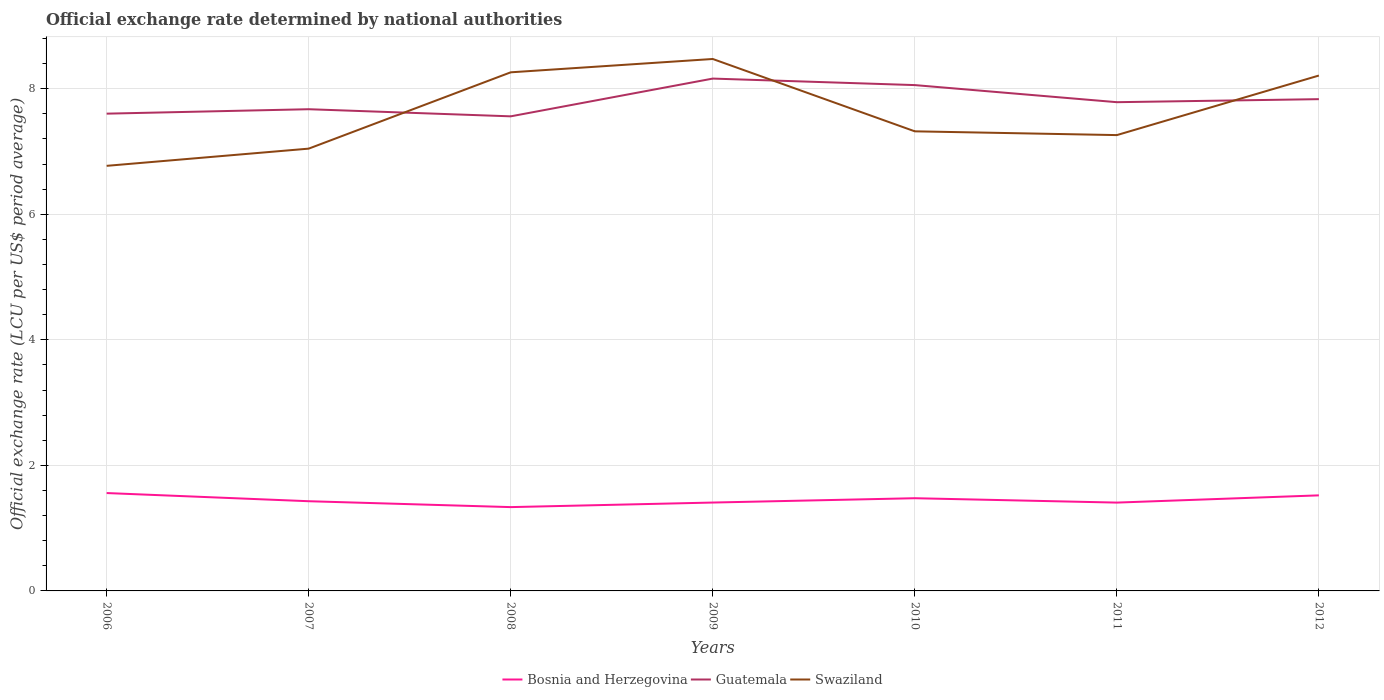How many different coloured lines are there?
Offer a very short reply. 3. Across all years, what is the maximum official exchange rate in Swaziland?
Keep it short and to the point. 6.77. What is the total official exchange rate in Swaziland in the graph?
Make the answer very short. -0.49. What is the difference between the highest and the second highest official exchange rate in Swaziland?
Ensure brevity in your answer.  1.7. Is the official exchange rate in Swaziland strictly greater than the official exchange rate in Guatemala over the years?
Give a very brief answer. No. Does the graph contain grids?
Provide a short and direct response. Yes. Where does the legend appear in the graph?
Provide a short and direct response. Bottom center. How are the legend labels stacked?
Ensure brevity in your answer.  Horizontal. What is the title of the graph?
Ensure brevity in your answer.  Official exchange rate determined by national authorities. Does "Peru" appear as one of the legend labels in the graph?
Give a very brief answer. No. What is the label or title of the X-axis?
Offer a very short reply. Years. What is the label or title of the Y-axis?
Give a very brief answer. Official exchange rate (LCU per US$ period average). What is the Official exchange rate (LCU per US$ period average) of Bosnia and Herzegovina in 2006?
Your answer should be very brief. 1.56. What is the Official exchange rate (LCU per US$ period average) of Guatemala in 2006?
Provide a succinct answer. 7.6. What is the Official exchange rate (LCU per US$ period average) of Swaziland in 2006?
Give a very brief answer. 6.77. What is the Official exchange rate (LCU per US$ period average) in Bosnia and Herzegovina in 2007?
Offer a terse response. 1.43. What is the Official exchange rate (LCU per US$ period average) of Guatemala in 2007?
Your answer should be very brief. 7.67. What is the Official exchange rate (LCU per US$ period average) in Swaziland in 2007?
Ensure brevity in your answer.  7.05. What is the Official exchange rate (LCU per US$ period average) of Bosnia and Herzegovina in 2008?
Offer a terse response. 1.34. What is the Official exchange rate (LCU per US$ period average) of Guatemala in 2008?
Keep it short and to the point. 7.56. What is the Official exchange rate (LCU per US$ period average) of Swaziland in 2008?
Keep it short and to the point. 8.26. What is the Official exchange rate (LCU per US$ period average) of Bosnia and Herzegovina in 2009?
Ensure brevity in your answer.  1.41. What is the Official exchange rate (LCU per US$ period average) of Guatemala in 2009?
Ensure brevity in your answer.  8.16. What is the Official exchange rate (LCU per US$ period average) of Swaziland in 2009?
Your answer should be very brief. 8.47. What is the Official exchange rate (LCU per US$ period average) of Bosnia and Herzegovina in 2010?
Your answer should be very brief. 1.48. What is the Official exchange rate (LCU per US$ period average) of Guatemala in 2010?
Provide a succinct answer. 8.06. What is the Official exchange rate (LCU per US$ period average) of Swaziland in 2010?
Provide a succinct answer. 7.32. What is the Official exchange rate (LCU per US$ period average) in Bosnia and Herzegovina in 2011?
Offer a very short reply. 1.41. What is the Official exchange rate (LCU per US$ period average) of Guatemala in 2011?
Make the answer very short. 7.79. What is the Official exchange rate (LCU per US$ period average) in Swaziland in 2011?
Offer a terse response. 7.26. What is the Official exchange rate (LCU per US$ period average) in Bosnia and Herzegovina in 2012?
Offer a terse response. 1.52. What is the Official exchange rate (LCU per US$ period average) in Guatemala in 2012?
Your answer should be very brief. 7.83. What is the Official exchange rate (LCU per US$ period average) of Swaziland in 2012?
Ensure brevity in your answer.  8.21. Across all years, what is the maximum Official exchange rate (LCU per US$ period average) of Bosnia and Herzegovina?
Provide a succinct answer. 1.56. Across all years, what is the maximum Official exchange rate (LCU per US$ period average) of Guatemala?
Offer a terse response. 8.16. Across all years, what is the maximum Official exchange rate (LCU per US$ period average) in Swaziland?
Provide a succinct answer. 8.47. Across all years, what is the minimum Official exchange rate (LCU per US$ period average) in Bosnia and Herzegovina?
Offer a very short reply. 1.34. Across all years, what is the minimum Official exchange rate (LCU per US$ period average) in Guatemala?
Keep it short and to the point. 7.56. Across all years, what is the minimum Official exchange rate (LCU per US$ period average) in Swaziland?
Ensure brevity in your answer.  6.77. What is the total Official exchange rate (LCU per US$ period average) of Bosnia and Herzegovina in the graph?
Offer a terse response. 10.14. What is the total Official exchange rate (LCU per US$ period average) in Guatemala in the graph?
Offer a terse response. 54.67. What is the total Official exchange rate (LCU per US$ period average) in Swaziland in the graph?
Your answer should be compact. 53.34. What is the difference between the Official exchange rate (LCU per US$ period average) of Bosnia and Herzegovina in 2006 and that in 2007?
Your response must be concise. 0.13. What is the difference between the Official exchange rate (LCU per US$ period average) of Guatemala in 2006 and that in 2007?
Your answer should be very brief. -0.07. What is the difference between the Official exchange rate (LCU per US$ period average) in Swaziland in 2006 and that in 2007?
Make the answer very short. -0.27. What is the difference between the Official exchange rate (LCU per US$ period average) of Bosnia and Herzegovina in 2006 and that in 2008?
Offer a very short reply. 0.22. What is the difference between the Official exchange rate (LCU per US$ period average) in Guatemala in 2006 and that in 2008?
Your answer should be very brief. 0.04. What is the difference between the Official exchange rate (LCU per US$ period average) of Swaziland in 2006 and that in 2008?
Offer a very short reply. -1.49. What is the difference between the Official exchange rate (LCU per US$ period average) of Bosnia and Herzegovina in 2006 and that in 2009?
Your answer should be compact. 0.15. What is the difference between the Official exchange rate (LCU per US$ period average) of Guatemala in 2006 and that in 2009?
Provide a short and direct response. -0.56. What is the difference between the Official exchange rate (LCU per US$ period average) in Swaziland in 2006 and that in 2009?
Your response must be concise. -1.7. What is the difference between the Official exchange rate (LCU per US$ period average) of Bosnia and Herzegovina in 2006 and that in 2010?
Offer a terse response. 0.08. What is the difference between the Official exchange rate (LCU per US$ period average) in Guatemala in 2006 and that in 2010?
Provide a short and direct response. -0.46. What is the difference between the Official exchange rate (LCU per US$ period average) in Swaziland in 2006 and that in 2010?
Ensure brevity in your answer.  -0.55. What is the difference between the Official exchange rate (LCU per US$ period average) of Bosnia and Herzegovina in 2006 and that in 2011?
Provide a short and direct response. 0.15. What is the difference between the Official exchange rate (LCU per US$ period average) of Guatemala in 2006 and that in 2011?
Make the answer very short. -0.18. What is the difference between the Official exchange rate (LCU per US$ period average) in Swaziland in 2006 and that in 2011?
Keep it short and to the point. -0.49. What is the difference between the Official exchange rate (LCU per US$ period average) of Bosnia and Herzegovina in 2006 and that in 2012?
Give a very brief answer. 0.04. What is the difference between the Official exchange rate (LCU per US$ period average) of Guatemala in 2006 and that in 2012?
Ensure brevity in your answer.  -0.23. What is the difference between the Official exchange rate (LCU per US$ period average) of Swaziland in 2006 and that in 2012?
Provide a succinct answer. -1.44. What is the difference between the Official exchange rate (LCU per US$ period average) of Bosnia and Herzegovina in 2007 and that in 2008?
Make the answer very short. 0.09. What is the difference between the Official exchange rate (LCU per US$ period average) of Guatemala in 2007 and that in 2008?
Provide a short and direct response. 0.11. What is the difference between the Official exchange rate (LCU per US$ period average) of Swaziland in 2007 and that in 2008?
Offer a very short reply. -1.22. What is the difference between the Official exchange rate (LCU per US$ period average) in Bosnia and Herzegovina in 2007 and that in 2009?
Make the answer very short. 0.02. What is the difference between the Official exchange rate (LCU per US$ period average) of Guatemala in 2007 and that in 2009?
Provide a succinct answer. -0.49. What is the difference between the Official exchange rate (LCU per US$ period average) in Swaziland in 2007 and that in 2009?
Offer a terse response. -1.43. What is the difference between the Official exchange rate (LCU per US$ period average) in Bosnia and Herzegovina in 2007 and that in 2010?
Ensure brevity in your answer.  -0.05. What is the difference between the Official exchange rate (LCU per US$ period average) of Guatemala in 2007 and that in 2010?
Give a very brief answer. -0.38. What is the difference between the Official exchange rate (LCU per US$ period average) of Swaziland in 2007 and that in 2010?
Keep it short and to the point. -0.28. What is the difference between the Official exchange rate (LCU per US$ period average) of Bosnia and Herzegovina in 2007 and that in 2011?
Make the answer very short. 0.02. What is the difference between the Official exchange rate (LCU per US$ period average) in Guatemala in 2007 and that in 2011?
Make the answer very short. -0.11. What is the difference between the Official exchange rate (LCU per US$ period average) of Swaziland in 2007 and that in 2011?
Your answer should be very brief. -0.22. What is the difference between the Official exchange rate (LCU per US$ period average) of Bosnia and Herzegovina in 2007 and that in 2012?
Your answer should be very brief. -0.09. What is the difference between the Official exchange rate (LCU per US$ period average) of Guatemala in 2007 and that in 2012?
Give a very brief answer. -0.16. What is the difference between the Official exchange rate (LCU per US$ period average) in Swaziland in 2007 and that in 2012?
Your response must be concise. -1.16. What is the difference between the Official exchange rate (LCU per US$ period average) of Bosnia and Herzegovina in 2008 and that in 2009?
Your answer should be very brief. -0.07. What is the difference between the Official exchange rate (LCU per US$ period average) of Guatemala in 2008 and that in 2009?
Provide a succinct answer. -0.6. What is the difference between the Official exchange rate (LCU per US$ period average) in Swaziland in 2008 and that in 2009?
Make the answer very short. -0.21. What is the difference between the Official exchange rate (LCU per US$ period average) of Bosnia and Herzegovina in 2008 and that in 2010?
Provide a short and direct response. -0.14. What is the difference between the Official exchange rate (LCU per US$ period average) in Guatemala in 2008 and that in 2010?
Give a very brief answer. -0.5. What is the difference between the Official exchange rate (LCU per US$ period average) in Bosnia and Herzegovina in 2008 and that in 2011?
Offer a terse response. -0.07. What is the difference between the Official exchange rate (LCU per US$ period average) of Guatemala in 2008 and that in 2011?
Your answer should be very brief. -0.23. What is the difference between the Official exchange rate (LCU per US$ period average) of Bosnia and Herzegovina in 2008 and that in 2012?
Your answer should be compact. -0.19. What is the difference between the Official exchange rate (LCU per US$ period average) in Guatemala in 2008 and that in 2012?
Provide a succinct answer. -0.27. What is the difference between the Official exchange rate (LCU per US$ period average) of Swaziland in 2008 and that in 2012?
Keep it short and to the point. 0.05. What is the difference between the Official exchange rate (LCU per US$ period average) of Bosnia and Herzegovina in 2009 and that in 2010?
Ensure brevity in your answer.  -0.07. What is the difference between the Official exchange rate (LCU per US$ period average) of Guatemala in 2009 and that in 2010?
Ensure brevity in your answer.  0.1. What is the difference between the Official exchange rate (LCU per US$ period average) of Swaziland in 2009 and that in 2010?
Provide a succinct answer. 1.15. What is the difference between the Official exchange rate (LCU per US$ period average) of Guatemala in 2009 and that in 2011?
Offer a very short reply. 0.38. What is the difference between the Official exchange rate (LCU per US$ period average) in Swaziland in 2009 and that in 2011?
Give a very brief answer. 1.21. What is the difference between the Official exchange rate (LCU per US$ period average) of Bosnia and Herzegovina in 2009 and that in 2012?
Your response must be concise. -0.11. What is the difference between the Official exchange rate (LCU per US$ period average) in Guatemala in 2009 and that in 2012?
Provide a succinct answer. 0.33. What is the difference between the Official exchange rate (LCU per US$ period average) of Swaziland in 2009 and that in 2012?
Offer a terse response. 0.26. What is the difference between the Official exchange rate (LCU per US$ period average) of Bosnia and Herzegovina in 2010 and that in 2011?
Make the answer very short. 0.07. What is the difference between the Official exchange rate (LCU per US$ period average) in Guatemala in 2010 and that in 2011?
Offer a very short reply. 0.27. What is the difference between the Official exchange rate (LCU per US$ period average) in Swaziland in 2010 and that in 2011?
Your response must be concise. 0.06. What is the difference between the Official exchange rate (LCU per US$ period average) of Bosnia and Herzegovina in 2010 and that in 2012?
Keep it short and to the point. -0.05. What is the difference between the Official exchange rate (LCU per US$ period average) in Guatemala in 2010 and that in 2012?
Keep it short and to the point. 0.22. What is the difference between the Official exchange rate (LCU per US$ period average) in Swaziland in 2010 and that in 2012?
Provide a short and direct response. -0.89. What is the difference between the Official exchange rate (LCU per US$ period average) in Bosnia and Herzegovina in 2011 and that in 2012?
Keep it short and to the point. -0.12. What is the difference between the Official exchange rate (LCU per US$ period average) of Guatemala in 2011 and that in 2012?
Ensure brevity in your answer.  -0.05. What is the difference between the Official exchange rate (LCU per US$ period average) in Swaziland in 2011 and that in 2012?
Offer a very short reply. -0.95. What is the difference between the Official exchange rate (LCU per US$ period average) of Bosnia and Herzegovina in 2006 and the Official exchange rate (LCU per US$ period average) of Guatemala in 2007?
Make the answer very short. -6.11. What is the difference between the Official exchange rate (LCU per US$ period average) in Bosnia and Herzegovina in 2006 and the Official exchange rate (LCU per US$ period average) in Swaziland in 2007?
Provide a succinct answer. -5.49. What is the difference between the Official exchange rate (LCU per US$ period average) in Guatemala in 2006 and the Official exchange rate (LCU per US$ period average) in Swaziland in 2007?
Your answer should be very brief. 0.56. What is the difference between the Official exchange rate (LCU per US$ period average) of Bosnia and Herzegovina in 2006 and the Official exchange rate (LCU per US$ period average) of Guatemala in 2008?
Provide a short and direct response. -6. What is the difference between the Official exchange rate (LCU per US$ period average) in Bosnia and Herzegovina in 2006 and the Official exchange rate (LCU per US$ period average) in Swaziland in 2008?
Your answer should be very brief. -6.7. What is the difference between the Official exchange rate (LCU per US$ period average) of Guatemala in 2006 and the Official exchange rate (LCU per US$ period average) of Swaziland in 2008?
Offer a very short reply. -0.66. What is the difference between the Official exchange rate (LCU per US$ period average) in Bosnia and Herzegovina in 2006 and the Official exchange rate (LCU per US$ period average) in Guatemala in 2009?
Give a very brief answer. -6.6. What is the difference between the Official exchange rate (LCU per US$ period average) of Bosnia and Herzegovina in 2006 and the Official exchange rate (LCU per US$ period average) of Swaziland in 2009?
Make the answer very short. -6.91. What is the difference between the Official exchange rate (LCU per US$ period average) of Guatemala in 2006 and the Official exchange rate (LCU per US$ period average) of Swaziland in 2009?
Your answer should be compact. -0.87. What is the difference between the Official exchange rate (LCU per US$ period average) in Bosnia and Herzegovina in 2006 and the Official exchange rate (LCU per US$ period average) in Guatemala in 2010?
Provide a succinct answer. -6.5. What is the difference between the Official exchange rate (LCU per US$ period average) of Bosnia and Herzegovina in 2006 and the Official exchange rate (LCU per US$ period average) of Swaziland in 2010?
Your response must be concise. -5.76. What is the difference between the Official exchange rate (LCU per US$ period average) of Guatemala in 2006 and the Official exchange rate (LCU per US$ period average) of Swaziland in 2010?
Offer a terse response. 0.28. What is the difference between the Official exchange rate (LCU per US$ period average) in Bosnia and Herzegovina in 2006 and the Official exchange rate (LCU per US$ period average) in Guatemala in 2011?
Offer a very short reply. -6.23. What is the difference between the Official exchange rate (LCU per US$ period average) in Bosnia and Herzegovina in 2006 and the Official exchange rate (LCU per US$ period average) in Swaziland in 2011?
Provide a succinct answer. -5.7. What is the difference between the Official exchange rate (LCU per US$ period average) of Guatemala in 2006 and the Official exchange rate (LCU per US$ period average) of Swaziland in 2011?
Your response must be concise. 0.34. What is the difference between the Official exchange rate (LCU per US$ period average) of Bosnia and Herzegovina in 2006 and the Official exchange rate (LCU per US$ period average) of Guatemala in 2012?
Your answer should be compact. -6.27. What is the difference between the Official exchange rate (LCU per US$ period average) of Bosnia and Herzegovina in 2006 and the Official exchange rate (LCU per US$ period average) of Swaziland in 2012?
Offer a terse response. -6.65. What is the difference between the Official exchange rate (LCU per US$ period average) in Guatemala in 2006 and the Official exchange rate (LCU per US$ period average) in Swaziland in 2012?
Offer a terse response. -0.61. What is the difference between the Official exchange rate (LCU per US$ period average) in Bosnia and Herzegovina in 2007 and the Official exchange rate (LCU per US$ period average) in Guatemala in 2008?
Your answer should be very brief. -6.13. What is the difference between the Official exchange rate (LCU per US$ period average) of Bosnia and Herzegovina in 2007 and the Official exchange rate (LCU per US$ period average) of Swaziland in 2008?
Make the answer very short. -6.83. What is the difference between the Official exchange rate (LCU per US$ period average) of Guatemala in 2007 and the Official exchange rate (LCU per US$ period average) of Swaziland in 2008?
Ensure brevity in your answer.  -0.59. What is the difference between the Official exchange rate (LCU per US$ period average) of Bosnia and Herzegovina in 2007 and the Official exchange rate (LCU per US$ period average) of Guatemala in 2009?
Your response must be concise. -6.73. What is the difference between the Official exchange rate (LCU per US$ period average) in Bosnia and Herzegovina in 2007 and the Official exchange rate (LCU per US$ period average) in Swaziland in 2009?
Ensure brevity in your answer.  -7.04. What is the difference between the Official exchange rate (LCU per US$ period average) in Guatemala in 2007 and the Official exchange rate (LCU per US$ period average) in Swaziland in 2009?
Make the answer very short. -0.8. What is the difference between the Official exchange rate (LCU per US$ period average) in Bosnia and Herzegovina in 2007 and the Official exchange rate (LCU per US$ period average) in Guatemala in 2010?
Offer a very short reply. -6.63. What is the difference between the Official exchange rate (LCU per US$ period average) in Bosnia and Herzegovina in 2007 and the Official exchange rate (LCU per US$ period average) in Swaziland in 2010?
Give a very brief answer. -5.89. What is the difference between the Official exchange rate (LCU per US$ period average) in Guatemala in 2007 and the Official exchange rate (LCU per US$ period average) in Swaziland in 2010?
Your answer should be very brief. 0.35. What is the difference between the Official exchange rate (LCU per US$ period average) of Bosnia and Herzegovina in 2007 and the Official exchange rate (LCU per US$ period average) of Guatemala in 2011?
Make the answer very short. -6.36. What is the difference between the Official exchange rate (LCU per US$ period average) in Bosnia and Herzegovina in 2007 and the Official exchange rate (LCU per US$ period average) in Swaziland in 2011?
Give a very brief answer. -5.83. What is the difference between the Official exchange rate (LCU per US$ period average) in Guatemala in 2007 and the Official exchange rate (LCU per US$ period average) in Swaziland in 2011?
Give a very brief answer. 0.41. What is the difference between the Official exchange rate (LCU per US$ period average) of Bosnia and Herzegovina in 2007 and the Official exchange rate (LCU per US$ period average) of Guatemala in 2012?
Keep it short and to the point. -6.4. What is the difference between the Official exchange rate (LCU per US$ period average) in Bosnia and Herzegovina in 2007 and the Official exchange rate (LCU per US$ period average) in Swaziland in 2012?
Offer a very short reply. -6.78. What is the difference between the Official exchange rate (LCU per US$ period average) of Guatemala in 2007 and the Official exchange rate (LCU per US$ period average) of Swaziland in 2012?
Provide a short and direct response. -0.54. What is the difference between the Official exchange rate (LCU per US$ period average) of Bosnia and Herzegovina in 2008 and the Official exchange rate (LCU per US$ period average) of Guatemala in 2009?
Ensure brevity in your answer.  -6.83. What is the difference between the Official exchange rate (LCU per US$ period average) in Bosnia and Herzegovina in 2008 and the Official exchange rate (LCU per US$ period average) in Swaziland in 2009?
Give a very brief answer. -7.14. What is the difference between the Official exchange rate (LCU per US$ period average) in Guatemala in 2008 and the Official exchange rate (LCU per US$ period average) in Swaziland in 2009?
Ensure brevity in your answer.  -0.91. What is the difference between the Official exchange rate (LCU per US$ period average) of Bosnia and Herzegovina in 2008 and the Official exchange rate (LCU per US$ period average) of Guatemala in 2010?
Offer a very short reply. -6.72. What is the difference between the Official exchange rate (LCU per US$ period average) in Bosnia and Herzegovina in 2008 and the Official exchange rate (LCU per US$ period average) in Swaziland in 2010?
Offer a terse response. -5.99. What is the difference between the Official exchange rate (LCU per US$ period average) of Guatemala in 2008 and the Official exchange rate (LCU per US$ period average) of Swaziland in 2010?
Make the answer very short. 0.24. What is the difference between the Official exchange rate (LCU per US$ period average) of Bosnia and Herzegovina in 2008 and the Official exchange rate (LCU per US$ period average) of Guatemala in 2011?
Offer a terse response. -6.45. What is the difference between the Official exchange rate (LCU per US$ period average) in Bosnia and Herzegovina in 2008 and the Official exchange rate (LCU per US$ period average) in Swaziland in 2011?
Keep it short and to the point. -5.93. What is the difference between the Official exchange rate (LCU per US$ period average) of Guatemala in 2008 and the Official exchange rate (LCU per US$ period average) of Swaziland in 2011?
Provide a succinct answer. 0.3. What is the difference between the Official exchange rate (LCU per US$ period average) of Bosnia and Herzegovina in 2008 and the Official exchange rate (LCU per US$ period average) of Guatemala in 2012?
Your answer should be very brief. -6.5. What is the difference between the Official exchange rate (LCU per US$ period average) of Bosnia and Herzegovina in 2008 and the Official exchange rate (LCU per US$ period average) of Swaziland in 2012?
Offer a terse response. -6.87. What is the difference between the Official exchange rate (LCU per US$ period average) in Guatemala in 2008 and the Official exchange rate (LCU per US$ period average) in Swaziland in 2012?
Ensure brevity in your answer.  -0.65. What is the difference between the Official exchange rate (LCU per US$ period average) of Bosnia and Herzegovina in 2009 and the Official exchange rate (LCU per US$ period average) of Guatemala in 2010?
Offer a very short reply. -6.65. What is the difference between the Official exchange rate (LCU per US$ period average) of Bosnia and Herzegovina in 2009 and the Official exchange rate (LCU per US$ period average) of Swaziland in 2010?
Your answer should be very brief. -5.91. What is the difference between the Official exchange rate (LCU per US$ period average) in Guatemala in 2009 and the Official exchange rate (LCU per US$ period average) in Swaziland in 2010?
Your response must be concise. 0.84. What is the difference between the Official exchange rate (LCU per US$ period average) of Bosnia and Herzegovina in 2009 and the Official exchange rate (LCU per US$ period average) of Guatemala in 2011?
Provide a short and direct response. -6.38. What is the difference between the Official exchange rate (LCU per US$ period average) in Bosnia and Herzegovina in 2009 and the Official exchange rate (LCU per US$ period average) in Swaziland in 2011?
Offer a very short reply. -5.85. What is the difference between the Official exchange rate (LCU per US$ period average) of Guatemala in 2009 and the Official exchange rate (LCU per US$ period average) of Swaziland in 2011?
Offer a very short reply. 0.9. What is the difference between the Official exchange rate (LCU per US$ period average) in Bosnia and Herzegovina in 2009 and the Official exchange rate (LCU per US$ period average) in Guatemala in 2012?
Your answer should be very brief. -6.43. What is the difference between the Official exchange rate (LCU per US$ period average) in Bosnia and Herzegovina in 2009 and the Official exchange rate (LCU per US$ period average) in Swaziland in 2012?
Provide a short and direct response. -6.8. What is the difference between the Official exchange rate (LCU per US$ period average) in Guatemala in 2009 and the Official exchange rate (LCU per US$ period average) in Swaziland in 2012?
Provide a short and direct response. -0.05. What is the difference between the Official exchange rate (LCU per US$ period average) of Bosnia and Herzegovina in 2010 and the Official exchange rate (LCU per US$ period average) of Guatemala in 2011?
Your answer should be compact. -6.31. What is the difference between the Official exchange rate (LCU per US$ period average) in Bosnia and Herzegovina in 2010 and the Official exchange rate (LCU per US$ period average) in Swaziland in 2011?
Offer a terse response. -5.78. What is the difference between the Official exchange rate (LCU per US$ period average) in Guatemala in 2010 and the Official exchange rate (LCU per US$ period average) in Swaziland in 2011?
Give a very brief answer. 0.8. What is the difference between the Official exchange rate (LCU per US$ period average) of Bosnia and Herzegovina in 2010 and the Official exchange rate (LCU per US$ period average) of Guatemala in 2012?
Your answer should be compact. -6.36. What is the difference between the Official exchange rate (LCU per US$ period average) in Bosnia and Herzegovina in 2010 and the Official exchange rate (LCU per US$ period average) in Swaziland in 2012?
Offer a terse response. -6.73. What is the difference between the Official exchange rate (LCU per US$ period average) of Guatemala in 2010 and the Official exchange rate (LCU per US$ period average) of Swaziland in 2012?
Keep it short and to the point. -0.15. What is the difference between the Official exchange rate (LCU per US$ period average) of Bosnia and Herzegovina in 2011 and the Official exchange rate (LCU per US$ period average) of Guatemala in 2012?
Keep it short and to the point. -6.43. What is the difference between the Official exchange rate (LCU per US$ period average) in Bosnia and Herzegovina in 2011 and the Official exchange rate (LCU per US$ period average) in Swaziland in 2012?
Provide a short and direct response. -6.8. What is the difference between the Official exchange rate (LCU per US$ period average) in Guatemala in 2011 and the Official exchange rate (LCU per US$ period average) in Swaziland in 2012?
Keep it short and to the point. -0.42. What is the average Official exchange rate (LCU per US$ period average) of Bosnia and Herzegovina per year?
Ensure brevity in your answer.  1.45. What is the average Official exchange rate (LCU per US$ period average) of Guatemala per year?
Keep it short and to the point. 7.81. What is the average Official exchange rate (LCU per US$ period average) in Swaziland per year?
Your response must be concise. 7.62. In the year 2006, what is the difference between the Official exchange rate (LCU per US$ period average) of Bosnia and Herzegovina and Official exchange rate (LCU per US$ period average) of Guatemala?
Offer a very short reply. -6.04. In the year 2006, what is the difference between the Official exchange rate (LCU per US$ period average) of Bosnia and Herzegovina and Official exchange rate (LCU per US$ period average) of Swaziland?
Keep it short and to the point. -5.21. In the year 2006, what is the difference between the Official exchange rate (LCU per US$ period average) in Guatemala and Official exchange rate (LCU per US$ period average) in Swaziland?
Keep it short and to the point. 0.83. In the year 2007, what is the difference between the Official exchange rate (LCU per US$ period average) in Bosnia and Herzegovina and Official exchange rate (LCU per US$ period average) in Guatemala?
Offer a terse response. -6.24. In the year 2007, what is the difference between the Official exchange rate (LCU per US$ period average) in Bosnia and Herzegovina and Official exchange rate (LCU per US$ period average) in Swaziland?
Offer a terse response. -5.62. In the year 2007, what is the difference between the Official exchange rate (LCU per US$ period average) in Guatemala and Official exchange rate (LCU per US$ period average) in Swaziland?
Provide a succinct answer. 0.63. In the year 2008, what is the difference between the Official exchange rate (LCU per US$ period average) in Bosnia and Herzegovina and Official exchange rate (LCU per US$ period average) in Guatemala?
Offer a terse response. -6.22. In the year 2008, what is the difference between the Official exchange rate (LCU per US$ period average) of Bosnia and Herzegovina and Official exchange rate (LCU per US$ period average) of Swaziland?
Offer a terse response. -6.93. In the year 2008, what is the difference between the Official exchange rate (LCU per US$ period average) in Guatemala and Official exchange rate (LCU per US$ period average) in Swaziland?
Ensure brevity in your answer.  -0.7. In the year 2009, what is the difference between the Official exchange rate (LCU per US$ period average) of Bosnia and Herzegovina and Official exchange rate (LCU per US$ period average) of Guatemala?
Offer a very short reply. -6.75. In the year 2009, what is the difference between the Official exchange rate (LCU per US$ period average) in Bosnia and Herzegovina and Official exchange rate (LCU per US$ period average) in Swaziland?
Your response must be concise. -7.07. In the year 2009, what is the difference between the Official exchange rate (LCU per US$ period average) of Guatemala and Official exchange rate (LCU per US$ period average) of Swaziland?
Provide a short and direct response. -0.31. In the year 2010, what is the difference between the Official exchange rate (LCU per US$ period average) of Bosnia and Herzegovina and Official exchange rate (LCU per US$ period average) of Guatemala?
Your answer should be compact. -6.58. In the year 2010, what is the difference between the Official exchange rate (LCU per US$ period average) in Bosnia and Herzegovina and Official exchange rate (LCU per US$ period average) in Swaziland?
Your response must be concise. -5.84. In the year 2010, what is the difference between the Official exchange rate (LCU per US$ period average) in Guatemala and Official exchange rate (LCU per US$ period average) in Swaziland?
Provide a short and direct response. 0.74. In the year 2011, what is the difference between the Official exchange rate (LCU per US$ period average) in Bosnia and Herzegovina and Official exchange rate (LCU per US$ period average) in Guatemala?
Give a very brief answer. -6.38. In the year 2011, what is the difference between the Official exchange rate (LCU per US$ period average) of Bosnia and Herzegovina and Official exchange rate (LCU per US$ period average) of Swaziland?
Offer a terse response. -5.85. In the year 2011, what is the difference between the Official exchange rate (LCU per US$ period average) in Guatemala and Official exchange rate (LCU per US$ period average) in Swaziland?
Keep it short and to the point. 0.52. In the year 2012, what is the difference between the Official exchange rate (LCU per US$ period average) in Bosnia and Herzegovina and Official exchange rate (LCU per US$ period average) in Guatemala?
Keep it short and to the point. -6.31. In the year 2012, what is the difference between the Official exchange rate (LCU per US$ period average) in Bosnia and Herzegovina and Official exchange rate (LCU per US$ period average) in Swaziland?
Provide a short and direct response. -6.69. In the year 2012, what is the difference between the Official exchange rate (LCU per US$ period average) of Guatemala and Official exchange rate (LCU per US$ period average) of Swaziland?
Keep it short and to the point. -0.38. What is the ratio of the Official exchange rate (LCU per US$ period average) in Bosnia and Herzegovina in 2006 to that in 2007?
Keep it short and to the point. 1.09. What is the ratio of the Official exchange rate (LCU per US$ period average) of Swaziland in 2006 to that in 2007?
Ensure brevity in your answer.  0.96. What is the ratio of the Official exchange rate (LCU per US$ period average) in Bosnia and Herzegovina in 2006 to that in 2008?
Your answer should be very brief. 1.17. What is the ratio of the Official exchange rate (LCU per US$ period average) of Guatemala in 2006 to that in 2008?
Your answer should be very brief. 1.01. What is the ratio of the Official exchange rate (LCU per US$ period average) of Swaziland in 2006 to that in 2008?
Offer a very short reply. 0.82. What is the ratio of the Official exchange rate (LCU per US$ period average) of Bosnia and Herzegovina in 2006 to that in 2009?
Offer a very short reply. 1.11. What is the ratio of the Official exchange rate (LCU per US$ period average) in Guatemala in 2006 to that in 2009?
Your answer should be very brief. 0.93. What is the ratio of the Official exchange rate (LCU per US$ period average) in Swaziland in 2006 to that in 2009?
Your answer should be very brief. 0.8. What is the ratio of the Official exchange rate (LCU per US$ period average) in Bosnia and Herzegovina in 2006 to that in 2010?
Offer a terse response. 1.06. What is the ratio of the Official exchange rate (LCU per US$ period average) in Guatemala in 2006 to that in 2010?
Provide a succinct answer. 0.94. What is the ratio of the Official exchange rate (LCU per US$ period average) in Swaziland in 2006 to that in 2010?
Offer a terse response. 0.92. What is the ratio of the Official exchange rate (LCU per US$ period average) in Bosnia and Herzegovina in 2006 to that in 2011?
Your response must be concise. 1.11. What is the ratio of the Official exchange rate (LCU per US$ period average) in Guatemala in 2006 to that in 2011?
Give a very brief answer. 0.98. What is the ratio of the Official exchange rate (LCU per US$ period average) of Swaziland in 2006 to that in 2011?
Offer a terse response. 0.93. What is the ratio of the Official exchange rate (LCU per US$ period average) of Bosnia and Herzegovina in 2006 to that in 2012?
Provide a short and direct response. 1.02. What is the ratio of the Official exchange rate (LCU per US$ period average) of Guatemala in 2006 to that in 2012?
Your answer should be compact. 0.97. What is the ratio of the Official exchange rate (LCU per US$ period average) of Swaziland in 2006 to that in 2012?
Your answer should be very brief. 0.82. What is the ratio of the Official exchange rate (LCU per US$ period average) of Bosnia and Herzegovina in 2007 to that in 2008?
Provide a succinct answer. 1.07. What is the ratio of the Official exchange rate (LCU per US$ period average) of Swaziland in 2007 to that in 2008?
Your response must be concise. 0.85. What is the ratio of the Official exchange rate (LCU per US$ period average) in Bosnia and Herzegovina in 2007 to that in 2009?
Provide a succinct answer. 1.01. What is the ratio of the Official exchange rate (LCU per US$ period average) in Guatemala in 2007 to that in 2009?
Offer a very short reply. 0.94. What is the ratio of the Official exchange rate (LCU per US$ period average) in Swaziland in 2007 to that in 2009?
Make the answer very short. 0.83. What is the ratio of the Official exchange rate (LCU per US$ period average) of Bosnia and Herzegovina in 2007 to that in 2010?
Ensure brevity in your answer.  0.97. What is the ratio of the Official exchange rate (LCU per US$ period average) of Guatemala in 2007 to that in 2010?
Offer a very short reply. 0.95. What is the ratio of the Official exchange rate (LCU per US$ period average) in Swaziland in 2007 to that in 2010?
Give a very brief answer. 0.96. What is the ratio of the Official exchange rate (LCU per US$ period average) of Bosnia and Herzegovina in 2007 to that in 2011?
Provide a short and direct response. 1.02. What is the ratio of the Official exchange rate (LCU per US$ period average) of Guatemala in 2007 to that in 2011?
Offer a terse response. 0.99. What is the ratio of the Official exchange rate (LCU per US$ period average) in Swaziland in 2007 to that in 2011?
Provide a short and direct response. 0.97. What is the ratio of the Official exchange rate (LCU per US$ period average) of Bosnia and Herzegovina in 2007 to that in 2012?
Give a very brief answer. 0.94. What is the ratio of the Official exchange rate (LCU per US$ period average) of Guatemala in 2007 to that in 2012?
Provide a succinct answer. 0.98. What is the ratio of the Official exchange rate (LCU per US$ period average) of Swaziland in 2007 to that in 2012?
Your response must be concise. 0.86. What is the ratio of the Official exchange rate (LCU per US$ period average) in Bosnia and Herzegovina in 2008 to that in 2009?
Your response must be concise. 0.95. What is the ratio of the Official exchange rate (LCU per US$ period average) in Guatemala in 2008 to that in 2009?
Make the answer very short. 0.93. What is the ratio of the Official exchange rate (LCU per US$ period average) of Swaziland in 2008 to that in 2009?
Ensure brevity in your answer.  0.97. What is the ratio of the Official exchange rate (LCU per US$ period average) in Bosnia and Herzegovina in 2008 to that in 2010?
Your answer should be compact. 0.9. What is the ratio of the Official exchange rate (LCU per US$ period average) in Guatemala in 2008 to that in 2010?
Offer a very short reply. 0.94. What is the ratio of the Official exchange rate (LCU per US$ period average) of Swaziland in 2008 to that in 2010?
Your answer should be very brief. 1.13. What is the ratio of the Official exchange rate (LCU per US$ period average) of Bosnia and Herzegovina in 2008 to that in 2011?
Your response must be concise. 0.95. What is the ratio of the Official exchange rate (LCU per US$ period average) in Guatemala in 2008 to that in 2011?
Offer a very short reply. 0.97. What is the ratio of the Official exchange rate (LCU per US$ period average) in Swaziland in 2008 to that in 2011?
Offer a very short reply. 1.14. What is the ratio of the Official exchange rate (LCU per US$ period average) of Bosnia and Herzegovina in 2008 to that in 2012?
Offer a terse response. 0.88. What is the ratio of the Official exchange rate (LCU per US$ period average) of Guatemala in 2008 to that in 2012?
Provide a succinct answer. 0.97. What is the ratio of the Official exchange rate (LCU per US$ period average) in Bosnia and Herzegovina in 2009 to that in 2010?
Keep it short and to the point. 0.95. What is the ratio of the Official exchange rate (LCU per US$ period average) in Guatemala in 2009 to that in 2010?
Make the answer very short. 1.01. What is the ratio of the Official exchange rate (LCU per US$ period average) of Swaziland in 2009 to that in 2010?
Your response must be concise. 1.16. What is the ratio of the Official exchange rate (LCU per US$ period average) in Bosnia and Herzegovina in 2009 to that in 2011?
Your answer should be compact. 1. What is the ratio of the Official exchange rate (LCU per US$ period average) in Guatemala in 2009 to that in 2011?
Give a very brief answer. 1.05. What is the ratio of the Official exchange rate (LCU per US$ period average) in Swaziland in 2009 to that in 2011?
Keep it short and to the point. 1.17. What is the ratio of the Official exchange rate (LCU per US$ period average) of Bosnia and Herzegovina in 2009 to that in 2012?
Ensure brevity in your answer.  0.92. What is the ratio of the Official exchange rate (LCU per US$ period average) of Guatemala in 2009 to that in 2012?
Provide a succinct answer. 1.04. What is the ratio of the Official exchange rate (LCU per US$ period average) of Swaziland in 2009 to that in 2012?
Give a very brief answer. 1.03. What is the ratio of the Official exchange rate (LCU per US$ period average) of Bosnia and Herzegovina in 2010 to that in 2011?
Your response must be concise. 1.05. What is the ratio of the Official exchange rate (LCU per US$ period average) of Guatemala in 2010 to that in 2011?
Ensure brevity in your answer.  1.03. What is the ratio of the Official exchange rate (LCU per US$ period average) of Swaziland in 2010 to that in 2011?
Make the answer very short. 1.01. What is the ratio of the Official exchange rate (LCU per US$ period average) of Bosnia and Herzegovina in 2010 to that in 2012?
Your answer should be very brief. 0.97. What is the ratio of the Official exchange rate (LCU per US$ period average) of Guatemala in 2010 to that in 2012?
Your answer should be very brief. 1.03. What is the ratio of the Official exchange rate (LCU per US$ period average) in Swaziland in 2010 to that in 2012?
Offer a terse response. 0.89. What is the ratio of the Official exchange rate (LCU per US$ period average) in Bosnia and Herzegovina in 2011 to that in 2012?
Give a very brief answer. 0.92. What is the ratio of the Official exchange rate (LCU per US$ period average) of Guatemala in 2011 to that in 2012?
Your answer should be very brief. 0.99. What is the ratio of the Official exchange rate (LCU per US$ period average) in Swaziland in 2011 to that in 2012?
Your answer should be compact. 0.88. What is the difference between the highest and the second highest Official exchange rate (LCU per US$ period average) of Bosnia and Herzegovina?
Your answer should be compact. 0.04. What is the difference between the highest and the second highest Official exchange rate (LCU per US$ period average) in Guatemala?
Keep it short and to the point. 0.1. What is the difference between the highest and the second highest Official exchange rate (LCU per US$ period average) in Swaziland?
Make the answer very short. 0.21. What is the difference between the highest and the lowest Official exchange rate (LCU per US$ period average) in Bosnia and Herzegovina?
Provide a succinct answer. 0.22. What is the difference between the highest and the lowest Official exchange rate (LCU per US$ period average) in Guatemala?
Your answer should be compact. 0.6. What is the difference between the highest and the lowest Official exchange rate (LCU per US$ period average) of Swaziland?
Keep it short and to the point. 1.7. 